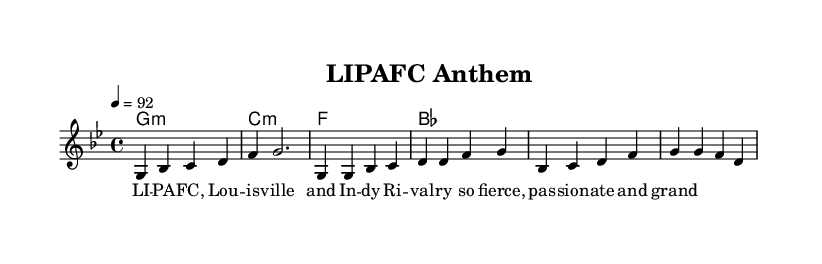What is the key signature of this music? The key signature is indicated by the two flats shown in the music notation, which corresponds to the key of G minor.
Answer: G minor What is the time signature of this music? The time signature is indicated at the beginning of the score, represented by the 4 over 4, meaning there are four beats in each measure.
Answer: 4/4 What is the tempo marking of this piece? The tempo marking is noted at the beginning with the quarter note equaling 92, indicating the speed of the piece.
Answer: 92 What is the primary theme of the lyrics? The lyrics focus on the local sports rivalry between Louisville and Indy, showcasing pride and passion associated with the teams.
Answer: Rivalry How many measures are present in the melody section? By counting the measures written in the melody part, there are a total of 4 measures in the melody section presented in the score.
Answer: 4 What chord follows the G minor chord in the progression? The chord structure is presented in a sequential format, and after the G minor chord, the next chord shown is C minor.
Answer: C minor What two teams are mentioned in the lyrics? The lyrics specifically mention Louisville and Indy, establishing the local sports teams that the anthem references.
Answer: Louisville and Indy 